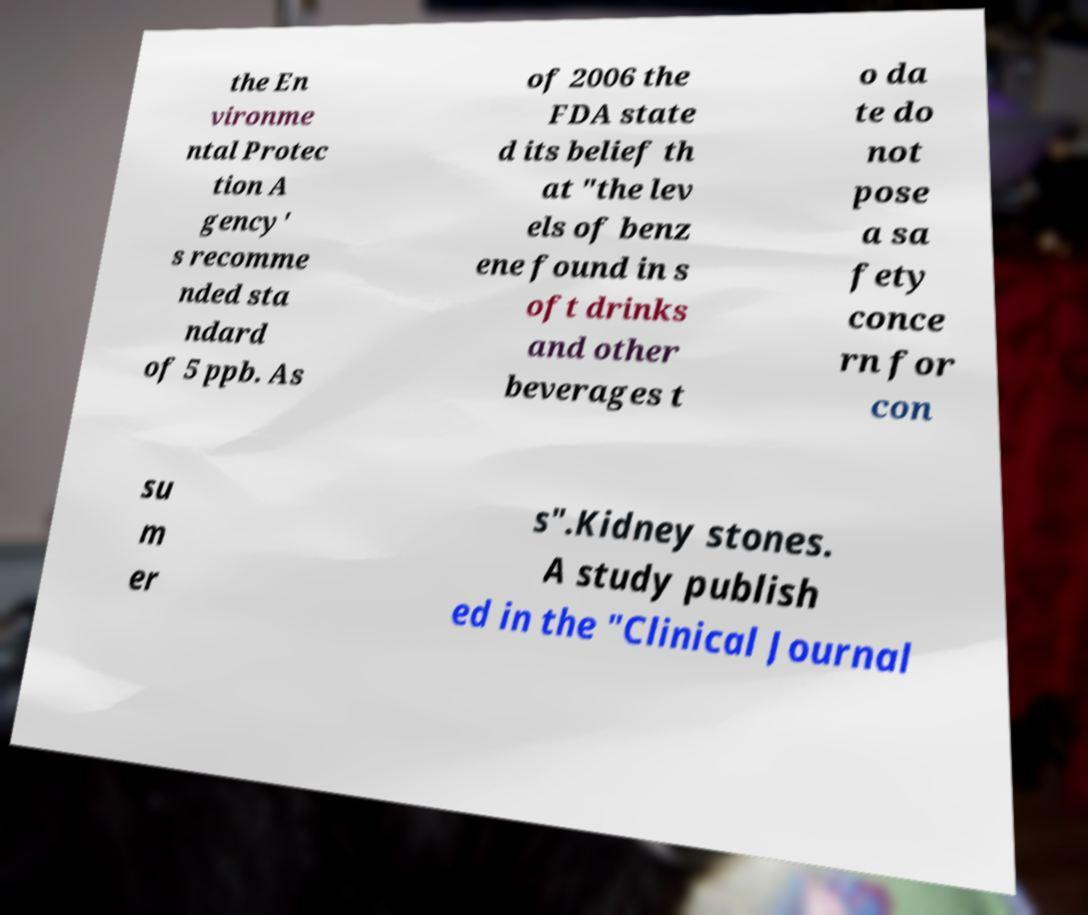Can you read and provide the text displayed in the image?This photo seems to have some interesting text. Can you extract and type it out for me? the En vironme ntal Protec tion A gency' s recomme nded sta ndard of 5 ppb. As of 2006 the FDA state d its belief th at "the lev els of benz ene found in s oft drinks and other beverages t o da te do not pose a sa fety conce rn for con su m er s".Kidney stones. A study publish ed in the "Clinical Journal 